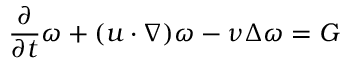<formula> <loc_0><loc_0><loc_500><loc_500>\frac { \partial } { \partial t } \omega + ( u \cdot \nabla ) \omega - \nu \Delta \omega = G</formula> 